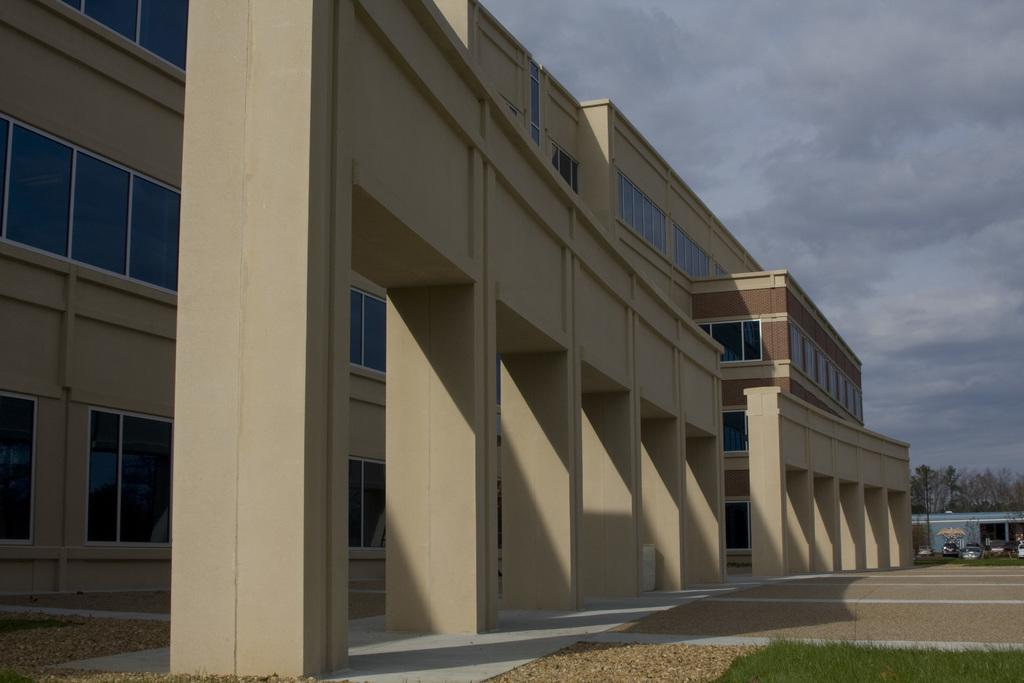What type of structures can be seen in the image? There are buildings in the image. What type of vegetation is visible in the image? There is grass visible in the image. What type of vehicles can be seen in the image? There are cars in the image. What type of natural elements are present in the image? There are trees in the image. What part of the natural environment is visible in the image? The sky is visible in the image. What is the condition of the sky in the image? Clouds are present in the sky. What type of cave can be seen in the image? There is no cave present in the image. How many answers are visible in the image? There are no answers present in the image; it is a visual representation, not a written or verbal one. 